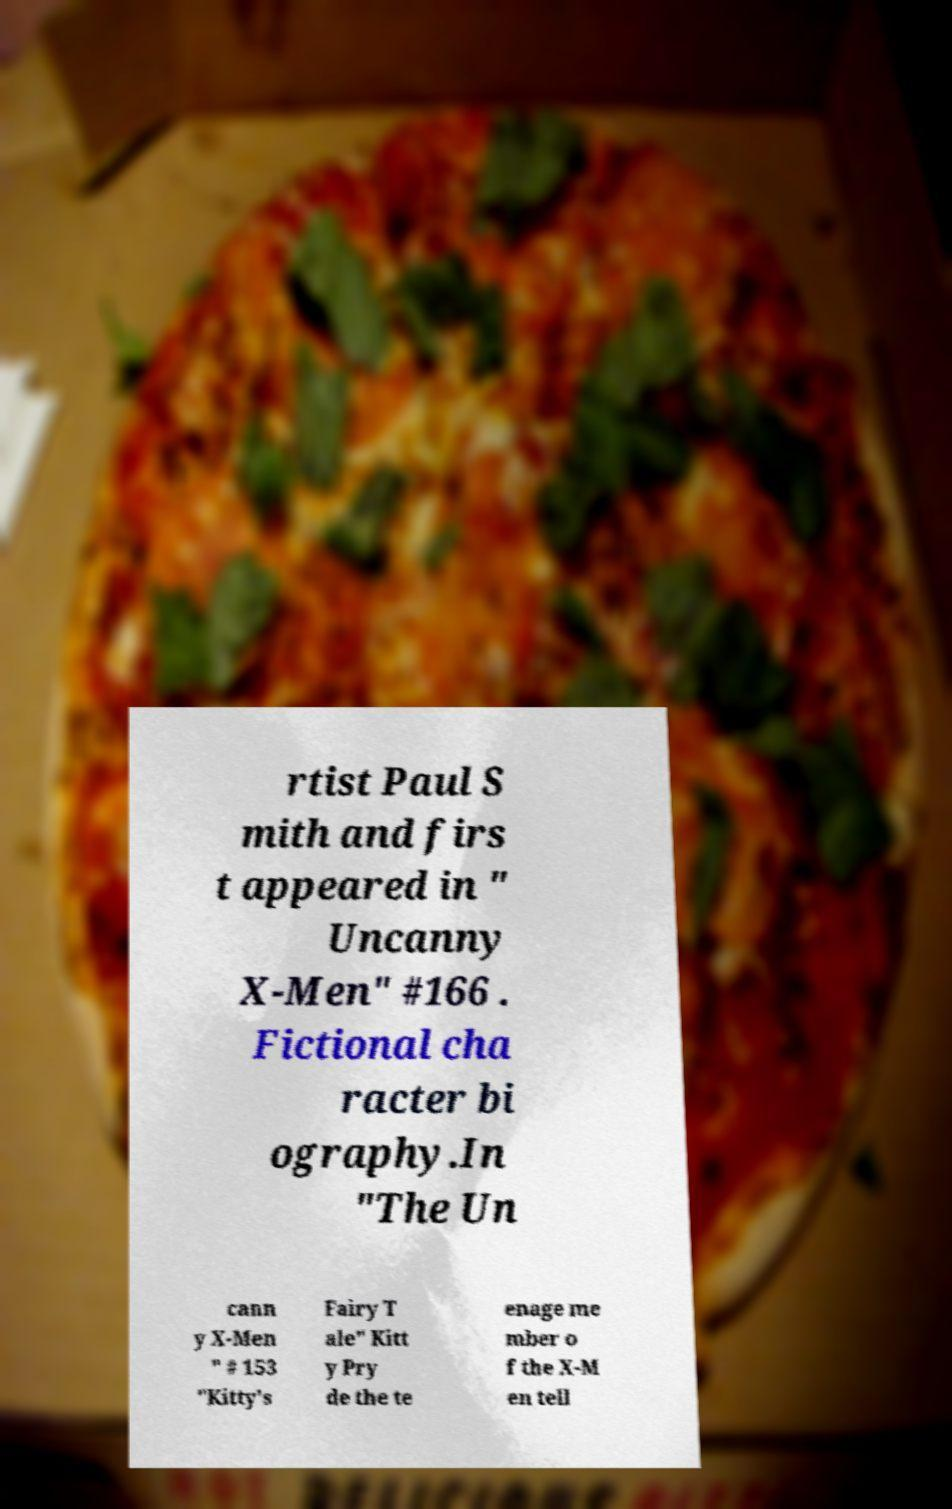Please read and relay the text visible in this image. What does it say? rtist Paul S mith and firs t appeared in " Uncanny X-Men" #166 . Fictional cha racter bi ography.In "The Un cann y X-Men " # 153 "Kitty's Fairy T ale" Kitt y Pry de the te enage me mber o f the X-M en tell 